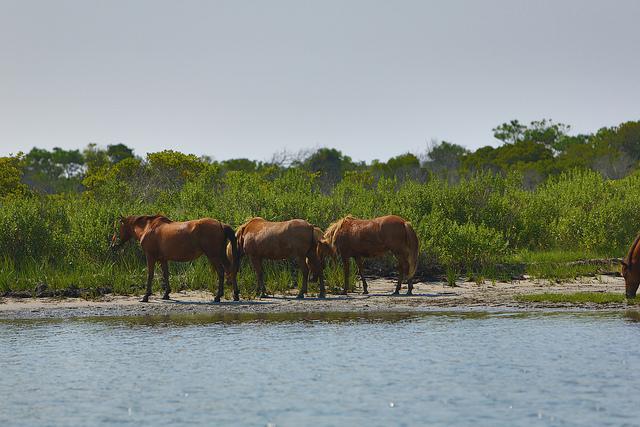Is there an animal in the water?
Answer briefly. No. How many horses are standing in the row?
Quick response, please. 3. What do you think this scene is portraying?
Quick response, please. Horses by sea. Is the horse on the right drinking water?
Give a very brief answer. Yes. Is the water calm?
Answer briefly. Yes. 